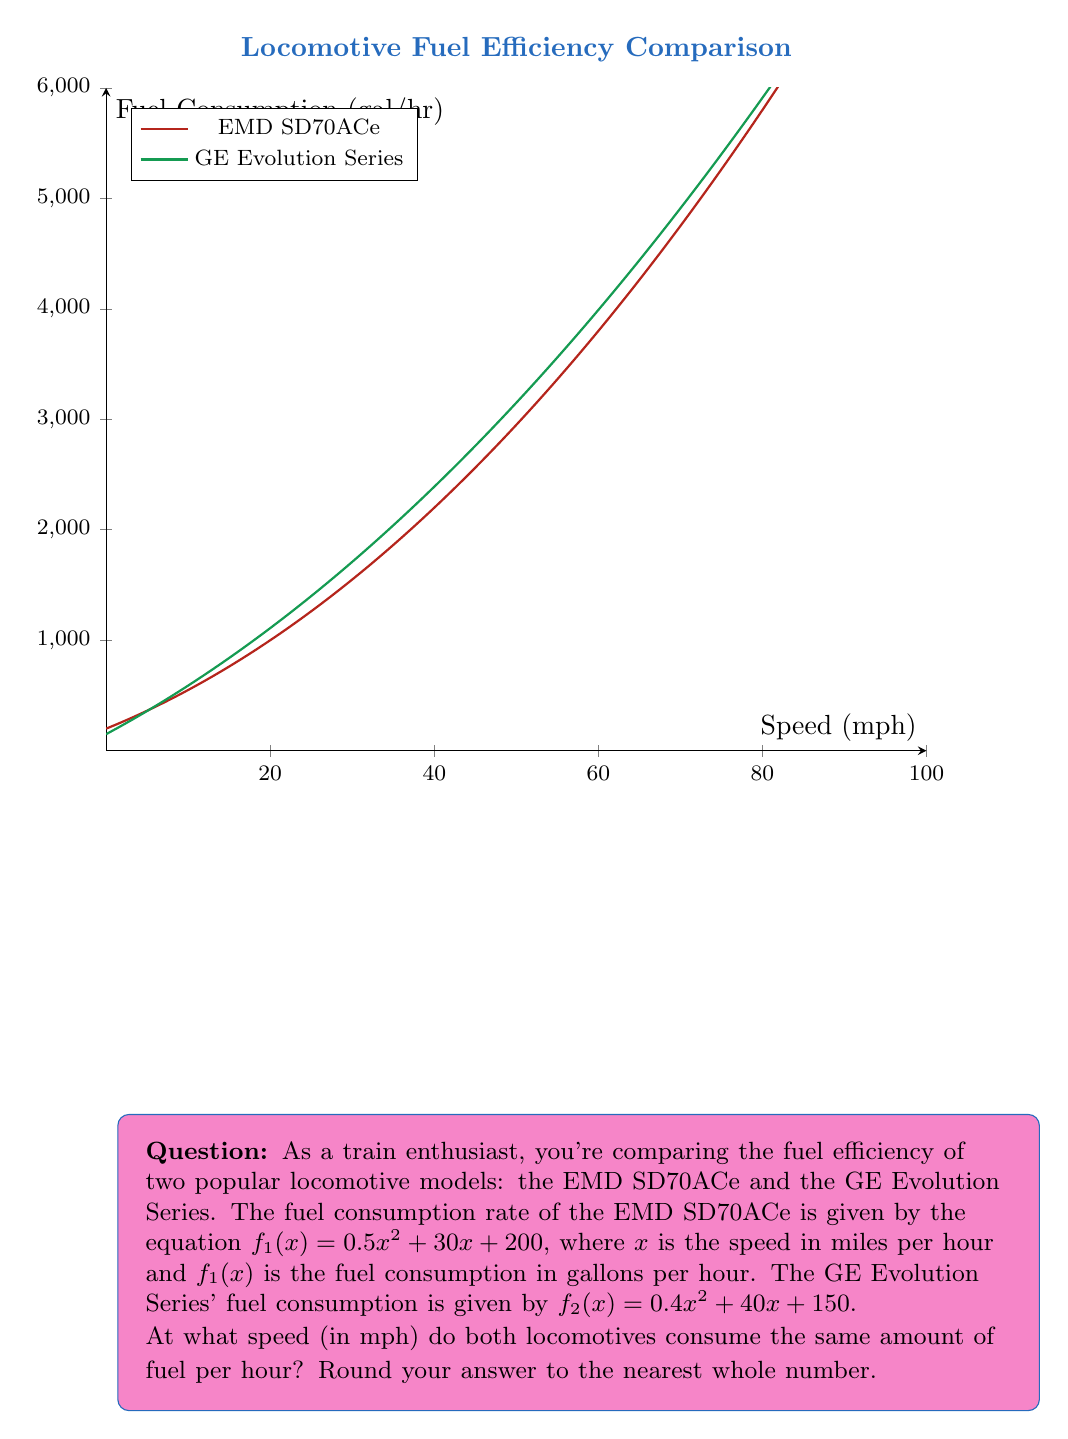Give your solution to this math problem. To find the speed at which both locomotives consume the same amount of fuel, we need to set the two equations equal to each other and solve for $x$:

$$f_1(x) = f_2(x)$$
$$(0.5x^2 + 30x + 200) = (0.4x^2 + 40x + 150)$$

Subtracting the right side from both sides:

$$0.5x^2 + 30x + 200 - (0.4x^2 + 40x + 150) = 0$$

Simplifying:

$$0.1x^2 - 10x + 50 = 0$$

This is a quadratic equation in the form $ax^2 + bx + c = 0$, where $a = 0.1$, $b = -10$, and $c = 50$.

We can solve this using the quadratic formula: $x = \frac{-b \pm \sqrt{b^2 - 4ac}}{2a}$

Substituting the values:

$$x = \frac{10 \pm \sqrt{(-10)^2 - 4(0.1)(50)}}{2(0.1)}$$

$$x = \frac{10 \pm \sqrt{100 - 20}}{0.2}$$

$$x = \frac{10 \pm \sqrt{80}}{0.2}$$

$$x = \frac{10 \pm 8.944}{0.2}$$

This gives us two solutions:

$$x_1 = \frac{10 + 8.944}{0.2} = 94.72$$
$$x_2 = \frac{10 - 8.944}{0.2} = 5.28$$

Since speed cannot be negative and we're looking for a realistic speed for train operation, we'll consider the positive solution: 94.72 mph.

Rounding to the nearest whole number, we get 95 mph.
Answer: 95 mph 